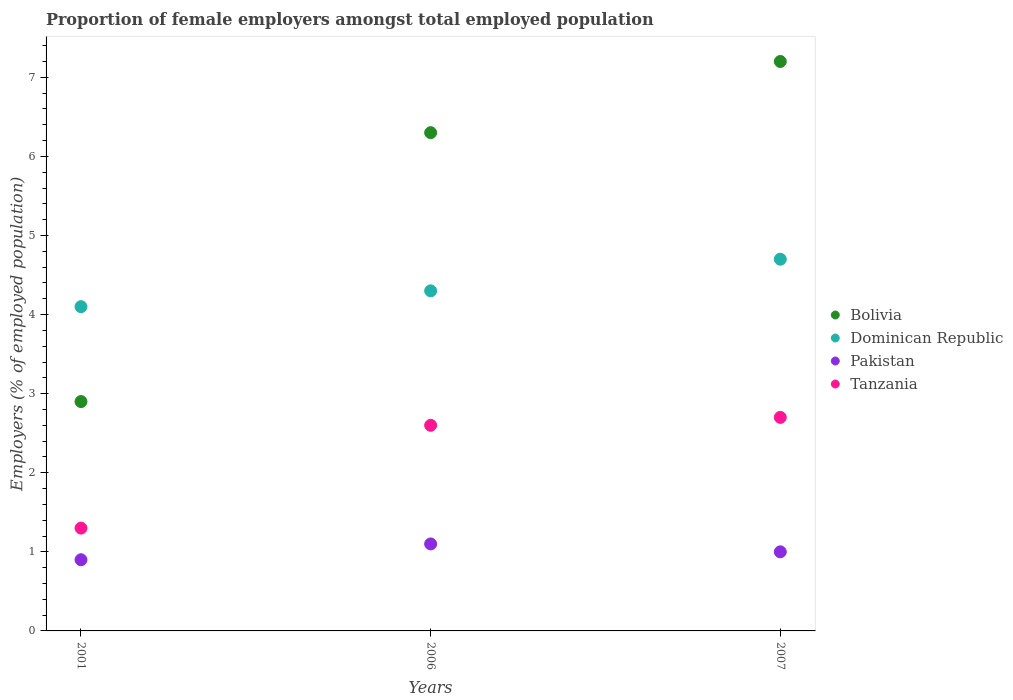How many different coloured dotlines are there?
Provide a short and direct response. 4. What is the proportion of female employers in Dominican Republic in 2001?
Ensure brevity in your answer.  4.1. Across all years, what is the maximum proportion of female employers in Bolivia?
Make the answer very short. 7.2. Across all years, what is the minimum proportion of female employers in Dominican Republic?
Provide a short and direct response. 4.1. In which year was the proportion of female employers in Dominican Republic maximum?
Ensure brevity in your answer.  2007. What is the total proportion of female employers in Tanzania in the graph?
Make the answer very short. 6.6. What is the difference between the proportion of female employers in Bolivia in 2006 and that in 2007?
Keep it short and to the point. -0.9. What is the difference between the proportion of female employers in Pakistan in 2006 and the proportion of female employers in Tanzania in 2001?
Your response must be concise. -0.2. What is the average proportion of female employers in Tanzania per year?
Offer a terse response. 2.2. In the year 2001, what is the difference between the proportion of female employers in Pakistan and proportion of female employers in Bolivia?
Offer a terse response. -2. In how many years, is the proportion of female employers in Pakistan greater than 6 %?
Keep it short and to the point. 0. What is the ratio of the proportion of female employers in Tanzania in 2001 to that in 2007?
Your answer should be compact. 0.48. Is the proportion of female employers in Pakistan in 2006 less than that in 2007?
Provide a short and direct response. No. Is the difference between the proportion of female employers in Pakistan in 2006 and 2007 greater than the difference between the proportion of female employers in Bolivia in 2006 and 2007?
Give a very brief answer. Yes. What is the difference between the highest and the second highest proportion of female employers in Pakistan?
Offer a terse response. 0.1. What is the difference between the highest and the lowest proportion of female employers in Dominican Republic?
Offer a very short reply. 0.6. Is the sum of the proportion of female employers in Pakistan in 2006 and 2007 greater than the maximum proportion of female employers in Dominican Republic across all years?
Provide a succinct answer. No. Is it the case that in every year, the sum of the proportion of female employers in Bolivia and proportion of female employers in Tanzania  is greater than the sum of proportion of female employers in Pakistan and proportion of female employers in Dominican Republic?
Provide a succinct answer. No. Is it the case that in every year, the sum of the proportion of female employers in Pakistan and proportion of female employers in Bolivia  is greater than the proportion of female employers in Tanzania?
Ensure brevity in your answer.  Yes. Does the proportion of female employers in Dominican Republic monotonically increase over the years?
Provide a short and direct response. Yes. Is the proportion of female employers in Dominican Republic strictly greater than the proportion of female employers in Pakistan over the years?
Offer a very short reply. Yes. How many dotlines are there?
Your answer should be compact. 4. How many years are there in the graph?
Make the answer very short. 3. Are the values on the major ticks of Y-axis written in scientific E-notation?
Your answer should be very brief. No. How many legend labels are there?
Make the answer very short. 4. What is the title of the graph?
Your answer should be compact. Proportion of female employers amongst total employed population. What is the label or title of the Y-axis?
Your answer should be very brief. Employers (% of employed population). What is the Employers (% of employed population) in Bolivia in 2001?
Offer a terse response. 2.9. What is the Employers (% of employed population) in Dominican Republic in 2001?
Provide a succinct answer. 4.1. What is the Employers (% of employed population) in Pakistan in 2001?
Your answer should be compact. 0.9. What is the Employers (% of employed population) in Tanzania in 2001?
Provide a short and direct response. 1.3. What is the Employers (% of employed population) in Bolivia in 2006?
Offer a very short reply. 6.3. What is the Employers (% of employed population) of Dominican Republic in 2006?
Your response must be concise. 4.3. What is the Employers (% of employed population) in Pakistan in 2006?
Ensure brevity in your answer.  1.1. What is the Employers (% of employed population) of Tanzania in 2006?
Give a very brief answer. 2.6. What is the Employers (% of employed population) of Bolivia in 2007?
Offer a very short reply. 7.2. What is the Employers (% of employed population) in Dominican Republic in 2007?
Ensure brevity in your answer.  4.7. What is the Employers (% of employed population) of Tanzania in 2007?
Provide a succinct answer. 2.7. Across all years, what is the maximum Employers (% of employed population) in Bolivia?
Provide a short and direct response. 7.2. Across all years, what is the maximum Employers (% of employed population) of Dominican Republic?
Your answer should be very brief. 4.7. Across all years, what is the maximum Employers (% of employed population) of Pakistan?
Make the answer very short. 1.1. Across all years, what is the maximum Employers (% of employed population) of Tanzania?
Offer a very short reply. 2.7. Across all years, what is the minimum Employers (% of employed population) of Bolivia?
Provide a succinct answer. 2.9. Across all years, what is the minimum Employers (% of employed population) in Dominican Republic?
Provide a succinct answer. 4.1. Across all years, what is the minimum Employers (% of employed population) of Pakistan?
Make the answer very short. 0.9. Across all years, what is the minimum Employers (% of employed population) of Tanzania?
Ensure brevity in your answer.  1.3. What is the total Employers (% of employed population) of Dominican Republic in the graph?
Give a very brief answer. 13.1. What is the difference between the Employers (% of employed population) of Pakistan in 2001 and that in 2006?
Provide a short and direct response. -0.2. What is the difference between the Employers (% of employed population) of Tanzania in 2001 and that in 2006?
Offer a terse response. -1.3. What is the difference between the Employers (% of employed population) of Bolivia in 2001 and that in 2007?
Ensure brevity in your answer.  -4.3. What is the difference between the Employers (% of employed population) in Dominican Republic in 2001 and that in 2007?
Provide a short and direct response. -0.6. What is the difference between the Employers (% of employed population) of Tanzania in 2001 and that in 2007?
Offer a very short reply. -1.4. What is the difference between the Employers (% of employed population) of Bolivia in 2006 and that in 2007?
Make the answer very short. -0.9. What is the difference between the Employers (% of employed population) of Dominican Republic in 2006 and that in 2007?
Give a very brief answer. -0.4. What is the difference between the Employers (% of employed population) in Bolivia in 2001 and the Employers (% of employed population) in Tanzania in 2006?
Make the answer very short. 0.3. What is the difference between the Employers (% of employed population) of Bolivia in 2001 and the Employers (% of employed population) of Dominican Republic in 2007?
Offer a very short reply. -1.8. What is the difference between the Employers (% of employed population) of Bolivia in 2001 and the Employers (% of employed population) of Pakistan in 2007?
Your response must be concise. 1.9. What is the difference between the Employers (% of employed population) of Bolivia in 2001 and the Employers (% of employed population) of Tanzania in 2007?
Provide a short and direct response. 0.2. What is the difference between the Employers (% of employed population) in Dominican Republic in 2001 and the Employers (% of employed population) in Pakistan in 2007?
Offer a very short reply. 3.1. What is the difference between the Employers (% of employed population) of Bolivia in 2006 and the Employers (% of employed population) of Pakistan in 2007?
Provide a succinct answer. 5.3. What is the difference between the Employers (% of employed population) of Dominican Republic in 2006 and the Employers (% of employed population) of Pakistan in 2007?
Ensure brevity in your answer.  3.3. What is the difference between the Employers (% of employed population) in Pakistan in 2006 and the Employers (% of employed population) in Tanzania in 2007?
Give a very brief answer. -1.6. What is the average Employers (% of employed population) of Bolivia per year?
Your answer should be compact. 5.47. What is the average Employers (% of employed population) of Dominican Republic per year?
Provide a short and direct response. 4.37. In the year 2001, what is the difference between the Employers (% of employed population) in Bolivia and Employers (% of employed population) in Pakistan?
Offer a very short reply. 2. In the year 2001, what is the difference between the Employers (% of employed population) of Pakistan and Employers (% of employed population) of Tanzania?
Your answer should be compact. -0.4. In the year 2006, what is the difference between the Employers (% of employed population) of Bolivia and Employers (% of employed population) of Dominican Republic?
Provide a short and direct response. 2. In the year 2006, what is the difference between the Employers (% of employed population) in Bolivia and Employers (% of employed population) in Tanzania?
Give a very brief answer. 3.7. In the year 2006, what is the difference between the Employers (% of employed population) in Dominican Republic and Employers (% of employed population) in Pakistan?
Provide a succinct answer. 3.2. In the year 2007, what is the difference between the Employers (% of employed population) of Bolivia and Employers (% of employed population) of Dominican Republic?
Offer a terse response. 2.5. In the year 2007, what is the difference between the Employers (% of employed population) in Bolivia and Employers (% of employed population) in Pakistan?
Your answer should be compact. 6.2. In the year 2007, what is the difference between the Employers (% of employed population) of Dominican Republic and Employers (% of employed population) of Pakistan?
Your response must be concise. 3.7. In the year 2007, what is the difference between the Employers (% of employed population) in Dominican Republic and Employers (% of employed population) in Tanzania?
Give a very brief answer. 2. What is the ratio of the Employers (% of employed population) of Bolivia in 2001 to that in 2006?
Your answer should be compact. 0.46. What is the ratio of the Employers (% of employed population) in Dominican Republic in 2001 to that in 2006?
Make the answer very short. 0.95. What is the ratio of the Employers (% of employed population) of Pakistan in 2001 to that in 2006?
Provide a succinct answer. 0.82. What is the ratio of the Employers (% of employed population) of Bolivia in 2001 to that in 2007?
Keep it short and to the point. 0.4. What is the ratio of the Employers (% of employed population) in Dominican Republic in 2001 to that in 2007?
Your response must be concise. 0.87. What is the ratio of the Employers (% of employed population) of Tanzania in 2001 to that in 2007?
Ensure brevity in your answer.  0.48. What is the ratio of the Employers (% of employed population) in Bolivia in 2006 to that in 2007?
Give a very brief answer. 0.88. What is the ratio of the Employers (% of employed population) of Dominican Republic in 2006 to that in 2007?
Provide a short and direct response. 0.91. What is the difference between the highest and the second highest Employers (% of employed population) in Bolivia?
Offer a terse response. 0.9. What is the difference between the highest and the second highest Employers (% of employed population) in Pakistan?
Your answer should be very brief. 0.1. What is the difference between the highest and the lowest Employers (% of employed population) in Tanzania?
Your answer should be very brief. 1.4. 